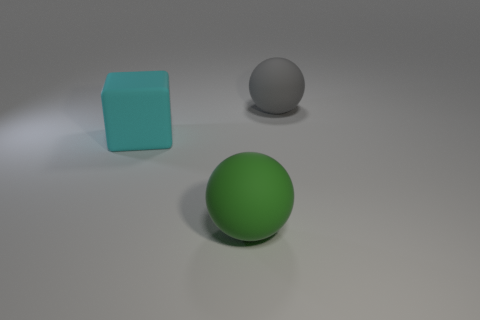What color is the other large rubber object that is the same shape as the big gray thing?
Your response must be concise. Green. Is there a big matte object left of the ball that is to the right of the big green ball in front of the gray sphere?
Offer a very short reply. Yes. Is the gray matte thing the same shape as the green matte object?
Offer a very short reply. Yes. Are there fewer large matte spheres behind the matte block than big gray balls?
Offer a very short reply. No. What is the color of the big matte thing left of the rubber ball that is in front of the large object that is to the left of the green sphere?
Offer a very short reply. Cyan. How many matte things are either green spheres or balls?
Your answer should be compact. 2. Is the green object the same size as the cyan block?
Keep it short and to the point. Yes. Are there fewer big green matte objects in front of the green rubber sphere than objects to the left of the large cube?
Offer a terse response. No. Is there any other thing that is the same size as the gray sphere?
Provide a short and direct response. Yes. The cyan matte object is what size?
Provide a short and direct response. Large. 